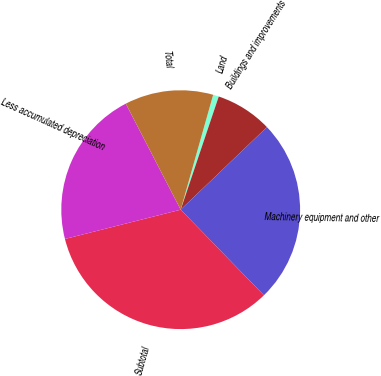Convert chart. <chart><loc_0><loc_0><loc_500><loc_500><pie_chart><fcel>Land<fcel>Buildings and improvements<fcel>Machinery equipment and other<fcel>Subtotal<fcel>Less accumulated depreciation<fcel>Total<nl><fcel>0.78%<fcel>7.68%<fcel>24.88%<fcel>33.33%<fcel>21.34%<fcel>11.99%<nl></chart> 